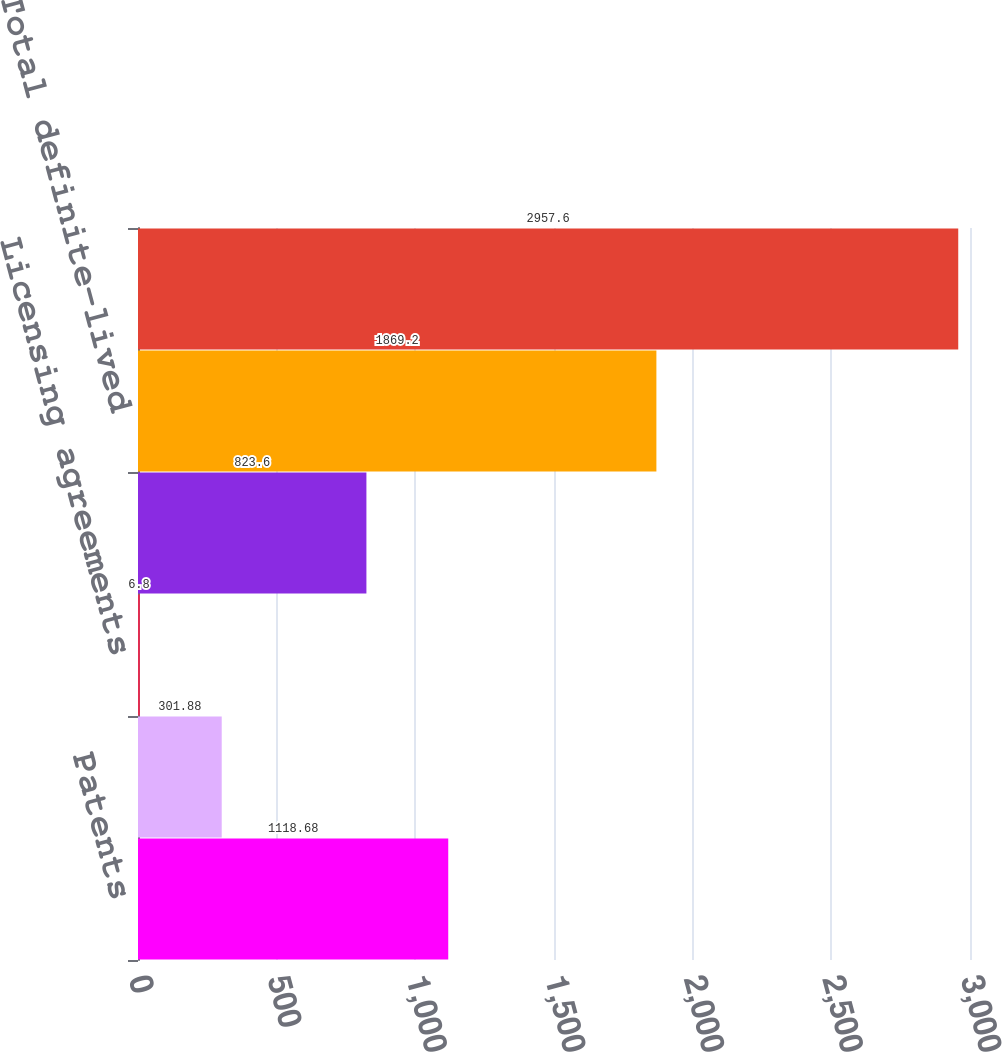Convert chart to OTSL. <chart><loc_0><loc_0><loc_500><loc_500><bar_chart><fcel>Patents<fcel>Trademarks<fcel>Licensing agreements<fcel>Customer relationships<fcel>Total definite-lived<fcel>Total identifiable intangible<nl><fcel>1118.68<fcel>301.88<fcel>6.8<fcel>823.6<fcel>1869.2<fcel>2957.6<nl></chart> 